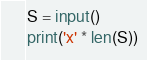<code> <loc_0><loc_0><loc_500><loc_500><_Python_>S = input()
print('x' * len(S))
</code> 